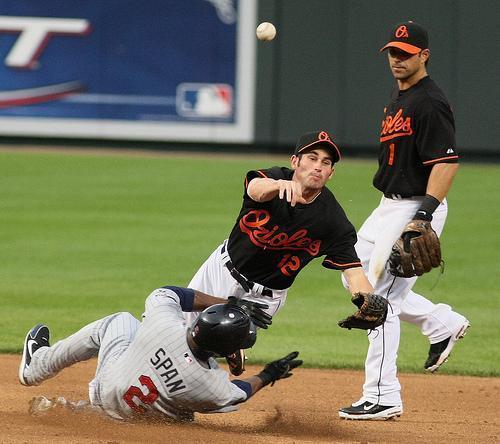How many players are there?
Give a very brief answer. 3. 